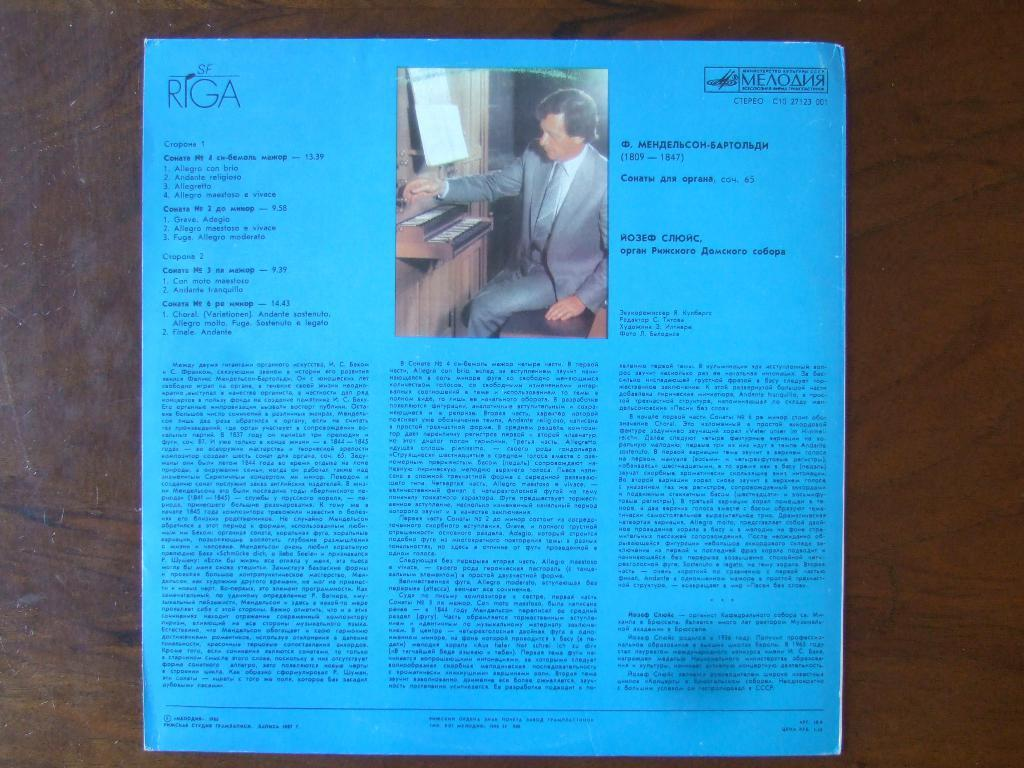What is on the paper that is visible in the image? There is a paper with writing on it in the image, and it also has a photo of a man on it. What is the color of the surface on which the paper is placed? The paper is on a brown color surface. What type of stew is being served in the image? There is no stew present in the image; it features a paper with writing and a photo of a man on a brown color surface. 